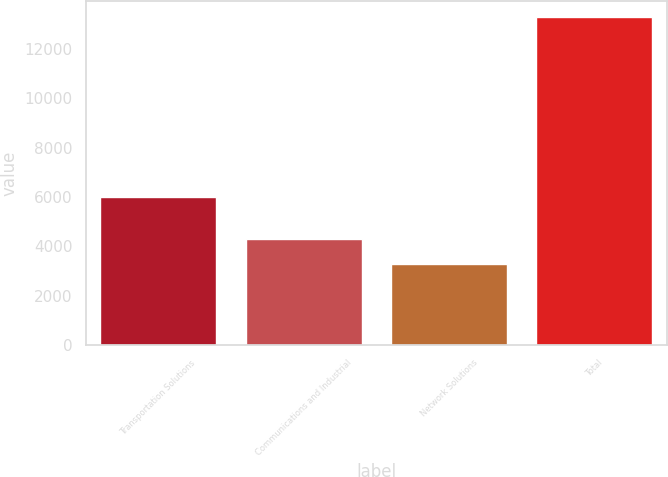Convert chart to OTSL. <chart><loc_0><loc_0><loc_500><loc_500><bar_chart><fcel>Transportation Solutions<fcel>Communications and Industrial<fcel>Network Solutions<fcel>Total<nl><fcel>6007<fcel>4284.7<fcel>3285<fcel>13282<nl></chart> 